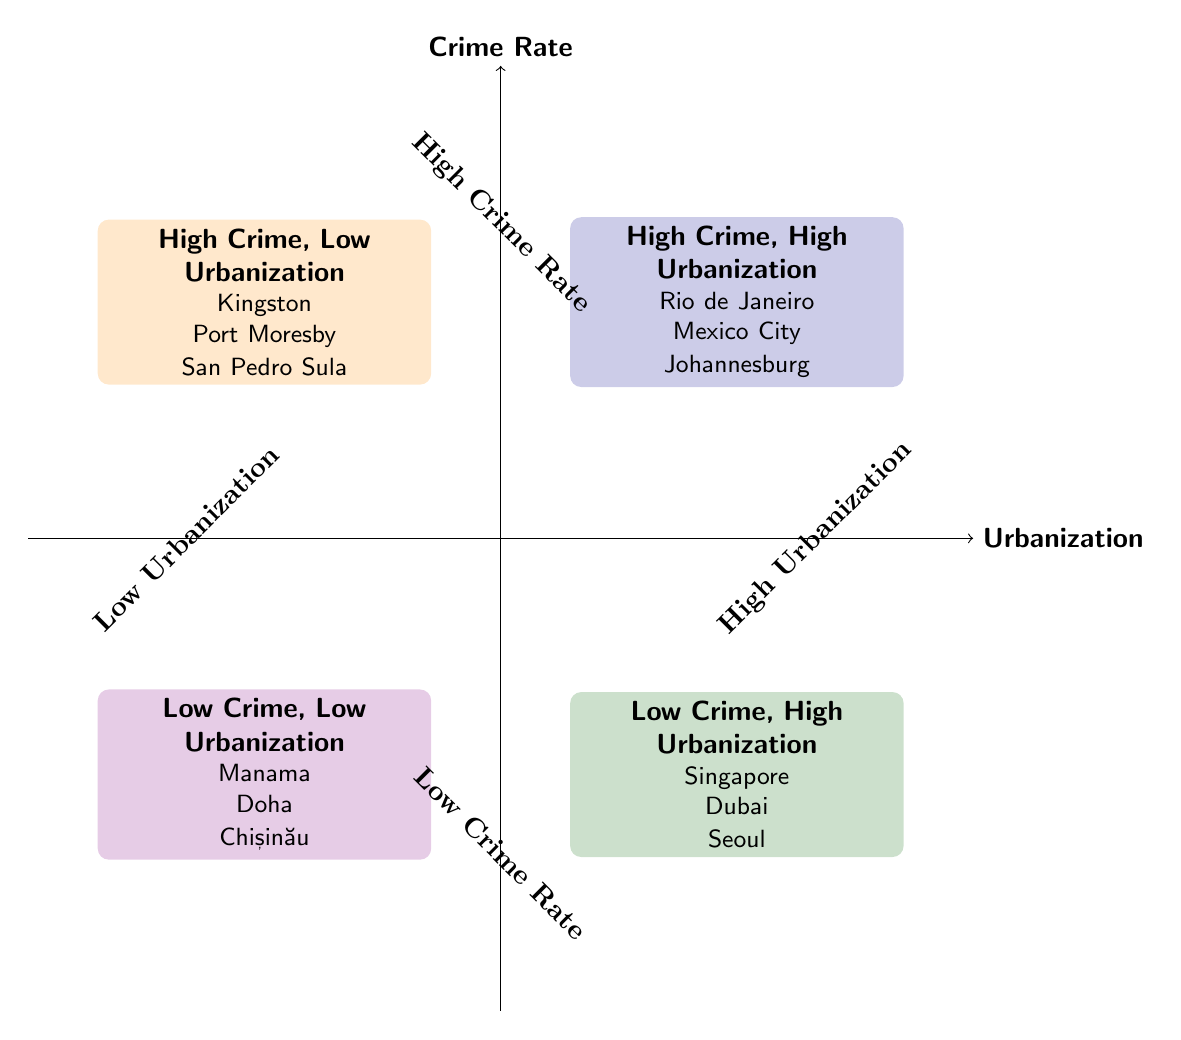What are some examples of cities in Quadrant 1? Quadrant 1 is labeled "High Crime Rate, High Urbanization." The examples listed in this quadrant include Rio de Janeiro, Johannesburg, and Mexico City.
Answer: Rio de Janeiro, Johannesburg, Mexico City Which quadrant contains Singapore? Singapore is found in Quadrant 2, which is labeled "Low Crime Rate, High Urbanization." Thus, the answer relates directly to the quadrant's classification.
Answer: Quadrant 2 What is a characteristic of cities in Quadrant 3? Quadrant 3 is labeled "High Crime Rate, Low Urbanization." One of the characteristics listed is "Limited economic opportunities," which associates directly with the cities in this quadrant.
Answer: Limited economic opportunities How many quadrants show a high crime rate? The quadrants that show a high crime rate are Quadrant 1 and Quadrant 3. Counting the number of these quadrants yields an answer of two.
Answer: 2 Which quadrant has strong social cohesion as a characteristic? The characteristic of strong social cohesion is associated with Quadrant 4, labeled "Low Crime Rate, Low Urbanization." This entails a specific aspect of that quadrant's conditions, leading to the answer.
Answer: Quadrant 4 Name a city in Quadrant 4. Quadrant 4 includes cities like Manama, Bahrain, as one of its examples. The question directly asks for a specific city from this quadrant.
Answer: Manama, Bahrain What is the relationship between high urbanization and crime rate in Quadrant 1? Quadrant 1 shows that high urbanization is accompanied by a high crime rate, evident from its label "High Crime Rate, High Urbanization." The interpretation connects urbanization with the crime statistics of the cities listed.
Answer: Positive relationship How does economic development relate to crime rate in Quadrant 2? In Quadrant 2, labeled "Low Crime Rate, High Urbanization," one characteristic is "High economic development." This suggests that increased economic development correlates with a reduced crime rate.
Answer: Negative relationship 